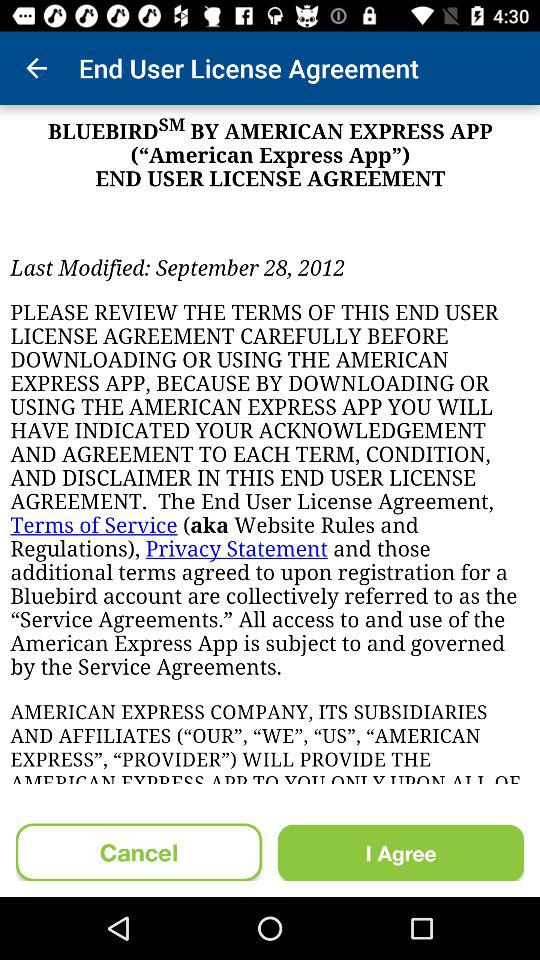When was the last modification made? The last modification was made on September 28, 2012. 